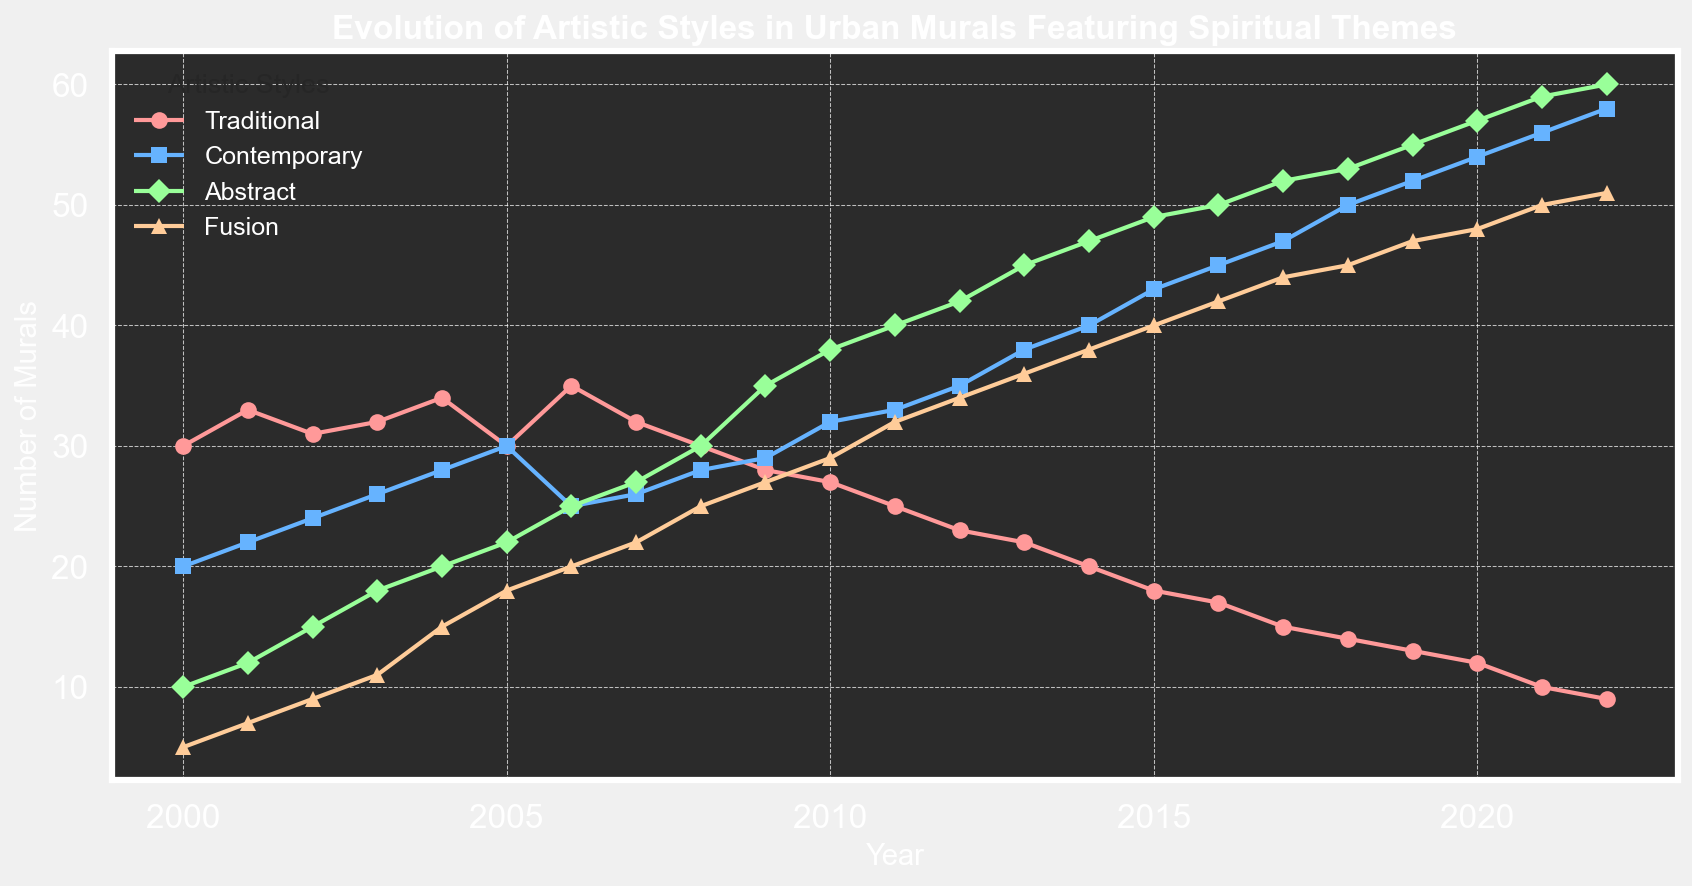what's the trend of "Abstract" art style from 2010 to 2015? Examine the plot line labeled "Abstract" from 2010 to 2015. The number rises consistently from 38 in 2010 to 49 in 2015.
Answer: Rising Which style had the highest number of murals in 2018? Check each year and compare the number of murals for each style in 2018. "Abstract" had 53, which is the highest among all styles in that year.
Answer: Abstract How do "Traditional" and "Contemporary" styles compare in 2020? Find the values for "Traditional" (12) and "Contemporary" (54) in 2020. "Contemporary" is significantly higher than "Traditional".
Answer: Contemporary is higher What's the combined number of "Fusion" and "Abstract" murals in 2013? Identify the values for "Fusion" (36) and "Abstract" (45) in 2013, then sum them: 36 + 45 = 81.
Answer: 81 Which year had the lowest number of "Traditional" murals? Look for the lowest point in the "Traditional" plot line. 2022 has the lowest number, which is 9.
Answer: 2022 Compare the growth rates of "Contemporary" and "Fusion" from 2000 to 2007. Which grew more? Calculate the difference for both styles from 2000 to 2007. "Contemporary" grew from 20 to 26 (6 murals), while "Fusion" grew from 5 to 22 (17 murals). "Fusion" grew more.
Answer: Fusion What's the overall trend of "Fusion" from 2006 to 2012? Assess the values from 2006 (20) to 2012 (34). There's a general upward trend.
Answer: Upward trend How many years did "Traditional" murals decrease continuously without interruptions? Locate the longest continuous downward trend in the "Traditional" plot line. It decreased continuously from 2014 (20) to 2022 (9), a span of 8 years.
Answer: 8 years Did "Contemporary" ever surpass "Abstract" from 2000 to 2022? Compare the lines of "Contemporary" and "Abstract" from 2000 to 2022. Around 2000-2009, "Contemporary" is higher; after 2011, "Abstract" surpasses.
Answer: Yes When did the "Fusion" style first exceed 20 murals? Identify the first point at which "Fusion" style exceeds 20. It first exceeds in 2005 (18 becomes 20 in 2006).
Answer: 2006 